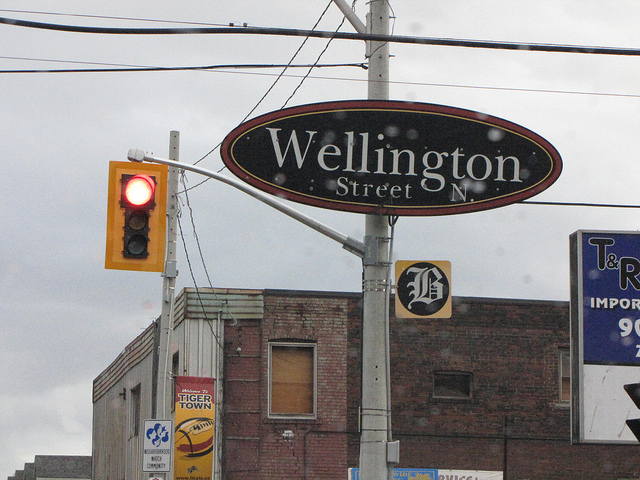Extract all visible text content from this image. Wellington Street N B TIGER 9 IMPOR R T TOWN 